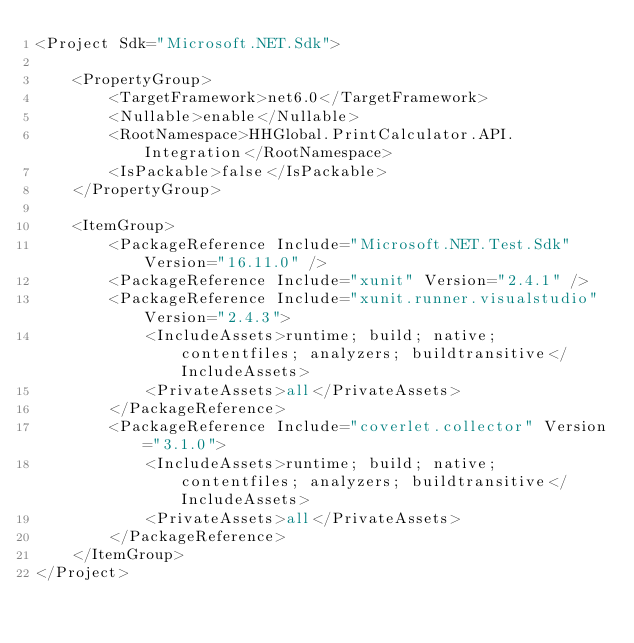<code> <loc_0><loc_0><loc_500><loc_500><_XML_><Project Sdk="Microsoft.NET.Sdk">

    <PropertyGroup>
        <TargetFramework>net6.0</TargetFramework>
        <Nullable>enable</Nullable>
        <RootNamespace>HHGlobal.PrintCalculator.API.Integration</RootNamespace>
        <IsPackable>false</IsPackable>
    </PropertyGroup>

    <ItemGroup>
        <PackageReference Include="Microsoft.NET.Test.Sdk" Version="16.11.0" />
        <PackageReference Include="xunit" Version="2.4.1" />
        <PackageReference Include="xunit.runner.visualstudio" Version="2.4.3">
            <IncludeAssets>runtime; build; native; contentfiles; analyzers; buildtransitive</IncludeAssets>
            <PrivateAssets>all</PrivateAssets>
        </PackageReference>
        <PackageReference Include="coverlet.collector" Version="3.1.0">
            <IncludeAssets>runtime; build; native; contentfiles; analyzers; buildtransitive</IncludeAssets>
            <PrivateAssets>all</PrivateAssets>
        </PackageReference>
    </ItemGroup>
</Project>
</code> 